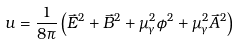Convert formula to latex. <formula><loc_0><loc_0><loc_500><loc_500>u = \frac { 1 } { 8 \pi } \left ( \vec { E } ^ { 2 } + \vec { B } ^ { 2 } + \mu _ { \gamma } ^ { 2 } \phi ^ { 2 } + \mu _ { \gamma } ^ { 2 } \vec { A } ^ { 2 } \right )</formula> 